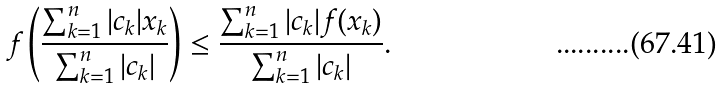<formula> <loc_0><loc_0><loc_500><loc_500>f \left ( \frac { \sum _ { k = 1 } ^ { n } | c _ { k } | x _ { k } } { \sum _ { k = 1 } ^ { n } | c _ { k } | } \right ) \leq \frac { \sum _ { k = 1 } ^ { n } | c _ { k } | f ( x _ { k } ) } { \sum _ { k = 1 } ^ { n } | c _ { k } | } .</formula> 